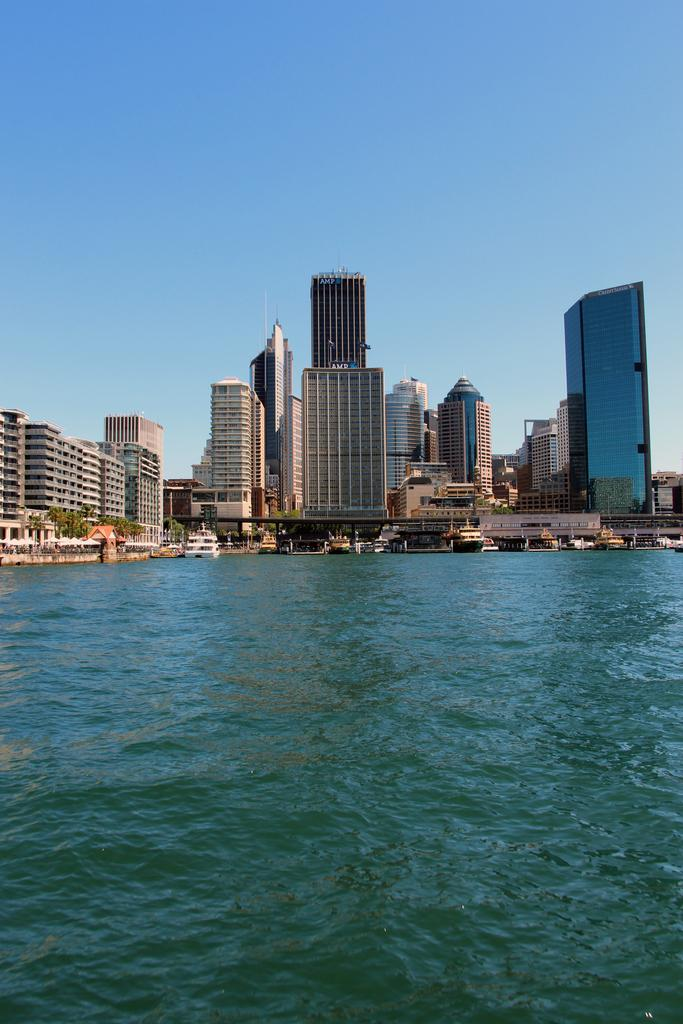What body of water is present in the image? There is a river in the image. What is on the river in the image? There are boats on the river. What can be seen in the distance in the image? There are buildings in the background of the image. What is visible above the buildings in the image? The sky is visible in the background of the image. What type of impulse can be seen affecting the boats in the image? There is no indication of any impulse affecting the boats in the image; they are simply floating on the river. 